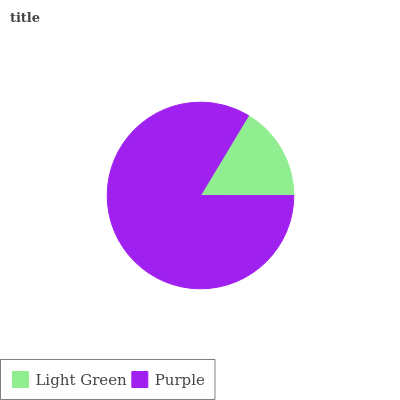Is Light Green the minimum?
Answer yes or no. Yes. Is Purple the maximum?
Answer yes or no. Yes. Is Purple the minimum?
Answer yes or no. No. Is Purple greater than Light Green?
Answer yes or no. Yes. Is Light Green less than Purple?
Answer yes or no. Yes. Is Light Green greater than Purple?
Answer yes or no. No. Is Purple less than Light Green?
Answer yes or no. No. Is Purple the high median?
Answer yes or no. Yes. Is Light Green the low median?
Answer yes or no. Yes. Is Light Green the high median?
Answer yes or no. No. Is Purple the low median?
Answer yes or no. No. 